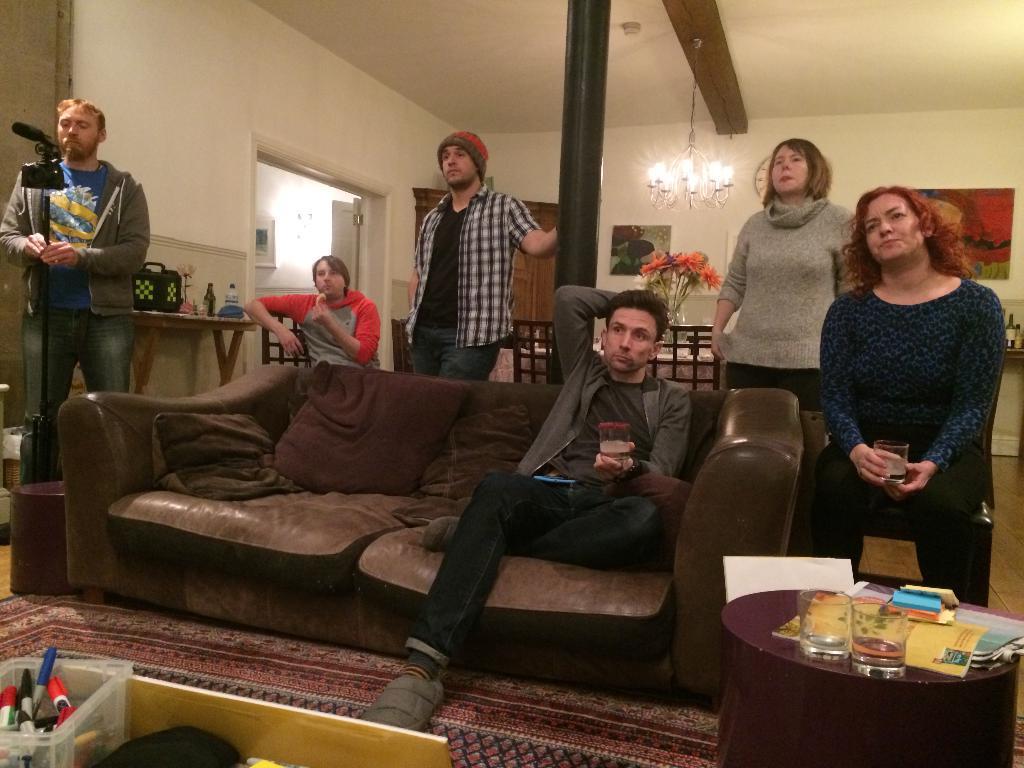Can you describe this image briefly? In this picture we can see a group of people where some are sitting on sofa with pillows on it an some are standing and in background we can see wall with frames, chandelier, pillar and in front of them there is table and on table we have glasses, books, boxes here person is holding camera. 